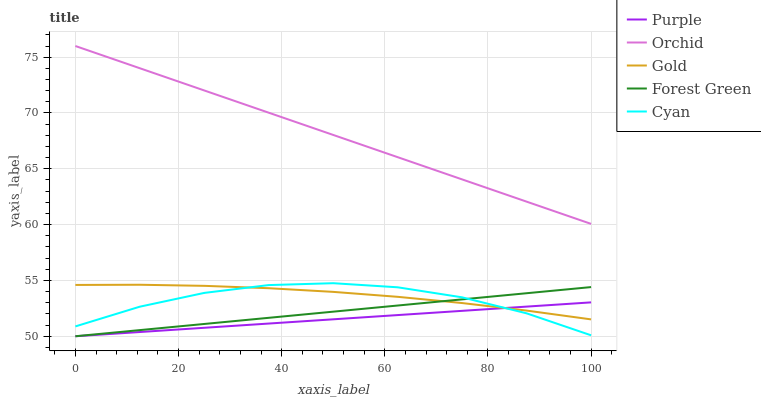Does Purple have the minimum area under the curve?
Answer yes or no. Yes. Does Orchid have the maximum area under the curve?
Answer yes or no. Yes. Does Cyan have the minimum area under the curve?
Answer yes or no. No. Does Cyan have the maximum area under the curve?
Answer yes or no. No. Is Purple the smoothest?
Answer yes or no. Yes. Is Cyan the roughest?
Answer yes or no. Yes. Is Forest Green the smoothest?
Answer yes or no. No. Is Forest Green the roughest?
Answer yes or no. No. Does Cyan have the lowest value?
Answer yes or no. No. Does Orchid have the highest value?
Answer yes or no. Yes. Does Cyan have the highest value?
Answer yes or no. No. Is Forest Green less than Orchid?
Answer yes or no. Yes. Is Orchid greater than Purple?
Answer yes or no. Yes. Does Cyan intersect Purple?
Answer yes or no. Yes. Is Cyan less than Purple?
Answer yes or no. No. Is Cyan greater than Purple?
Answer yes or no. No. Does Forest Green intersect Orchid?
Answer yes or no. No. 